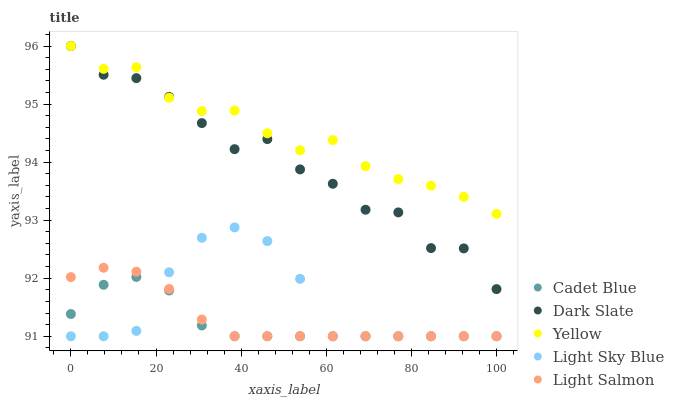Does Cadet Blue have the minimum area under the curve?
Answer yes or no. Yes. Does Yellow have the maximum area under the curve?
Answer yes or no. Yes. Does Light Salmon have the minimum area under the curve?
Answer yes or no. No. Does Light Salmon have the maximum area under the curve?
Answer yes or no. No. Is Light Salmon the smoothest?
Answer yes or no. Yes. Is Dark Slate the roughest?
Answer yes or no. Yes. Is Cadet Blue the smoothest?
Answer yes or no. No. Is Cadet Blue the roughest?
Answer yes or no. No. Does Light Salmon have the lowest value?
Answer yes or no. Yes. Does Yellow have the lowest value?
Answer yes or no. No. Does Yellow have the highest value?
Answer yes or no. Yes. Does Light Salmon have the highest value?
Answer yes or no. No. Is Light Sky Blue less than Yellow?
Answer yes or no. Yes. Is Dark Slate greater than Light Sky Blue?
Answer yes or no. Yes. Does Yellow intersect Dark Slate?
Answer yes or no. Yes. Is Yellow less than Dark Slate?
Answer yes or no. No. Is Yellow greater than Dark Slate?
Answer yes or no. No. Does Light Sky Blue intersect Yellow?
Answer yes or no. No. 